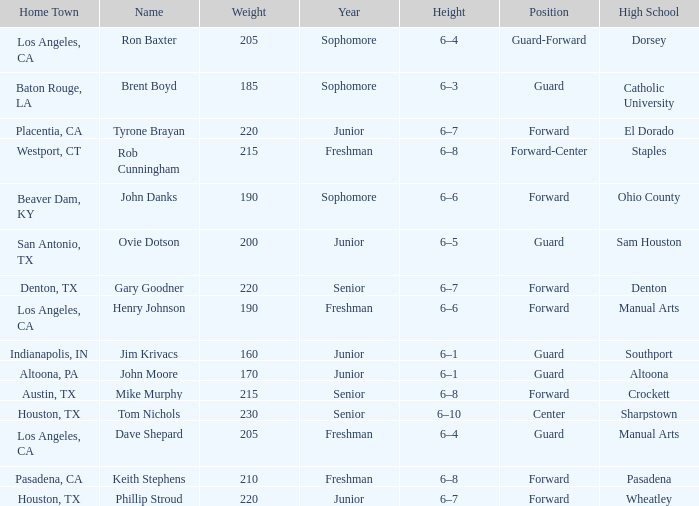What is the Position with a Year with freshman, and a Weight larger than 210? Forward-Center. 